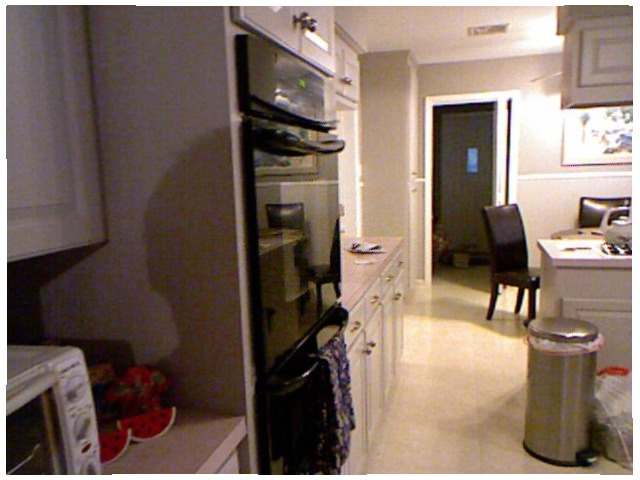<image>
Is there a watermelon on the kitchen platform? Yes. Looking at the image, I can see the watermelon is positioned on top of the kitchen platform, with the kitchen platform providing support. Is the table behind the dustbin? Yes. From this viewpoint, the table is positioned behind the dustbin, with the dustbin partially or fully occluding the table. 